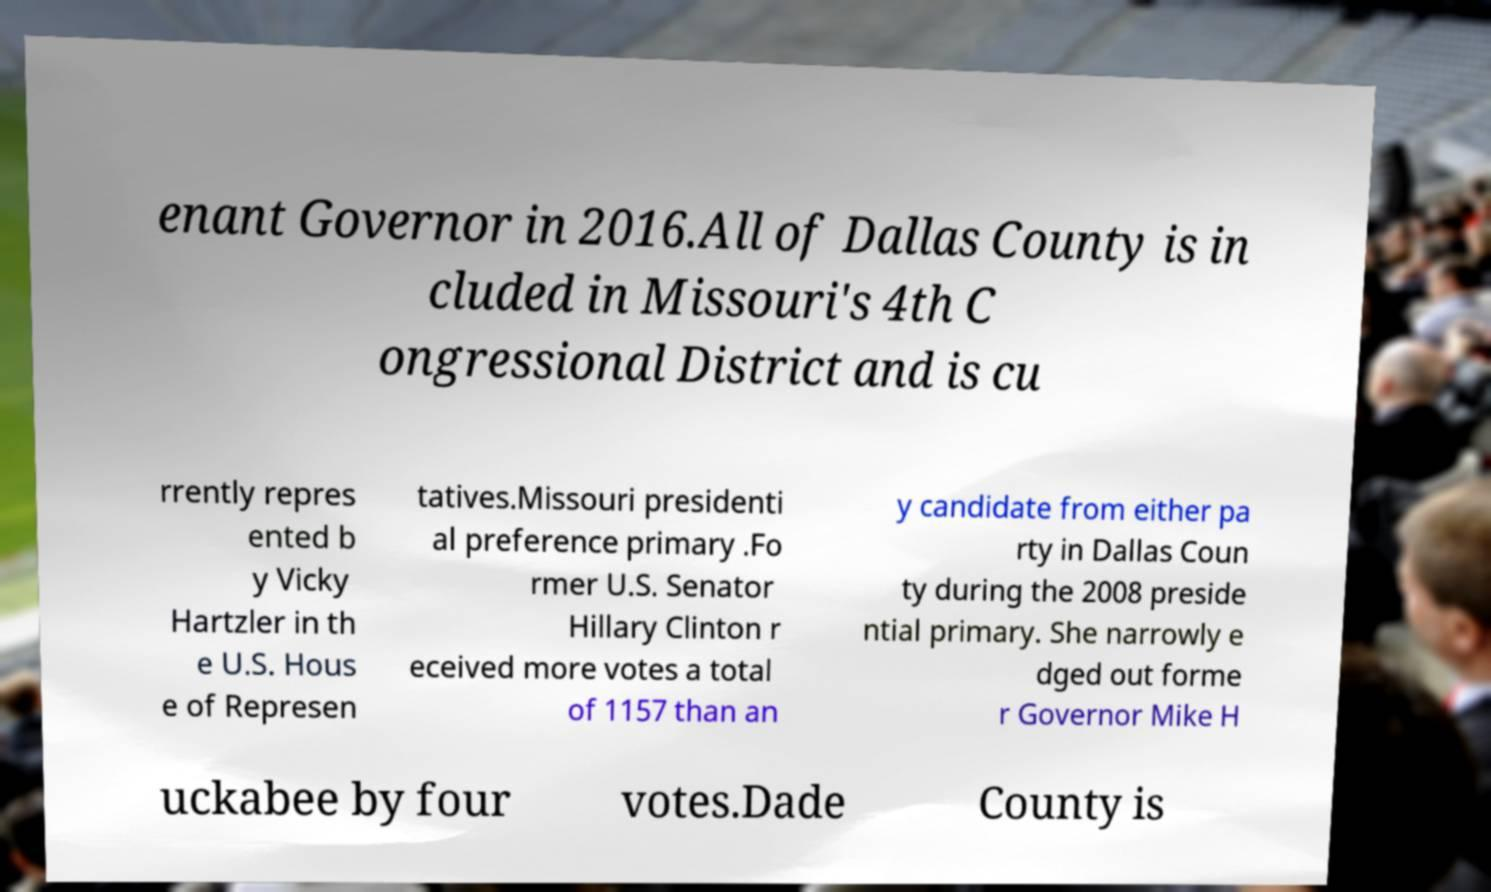Can you read and provide the text displayed in the image?This photo seems to have some interesting text. Can you extract and type it out for me? enant Governor in 2016.All of Dallas County is in cluded in Missouri's 4th C ongressional District and is cu rrently repres ented b y Vicky Hartzler in th e U.S. Hous e of Represen tatives.Missouri presidenti al preference primary .Fo rmer U.S. Senator Hillary Clinton r eceived more votes a total of 1157 than an y candidate from either pa rty in Dallas Coun ty during the 2008 preside ntial primary. She narrowly e dged out forme r Governor Mike H uckabee by four votes.Dade County is 